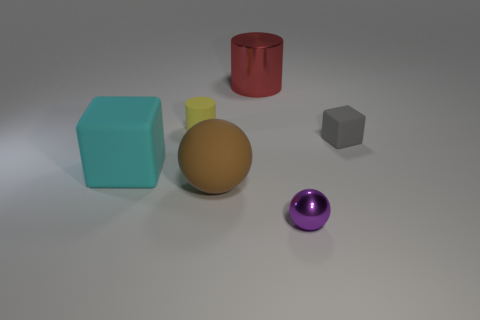Subtract all brown cubes. Subtract all yellow cylinders. How many cubes are left? 2 Add 1 brown rubber cylinders. How many objects exist? 7 Add 5 gray matte cubes. How many gray matte cubes exist? 6 Subtract 0 blue spheres. How many objects are left? 6 Subtract all small matte cylinders. Subtract all small yellow matte things. How many objects are left? 4 Add 5 brown matte spheres. How many brown matte spheres are left? 6 